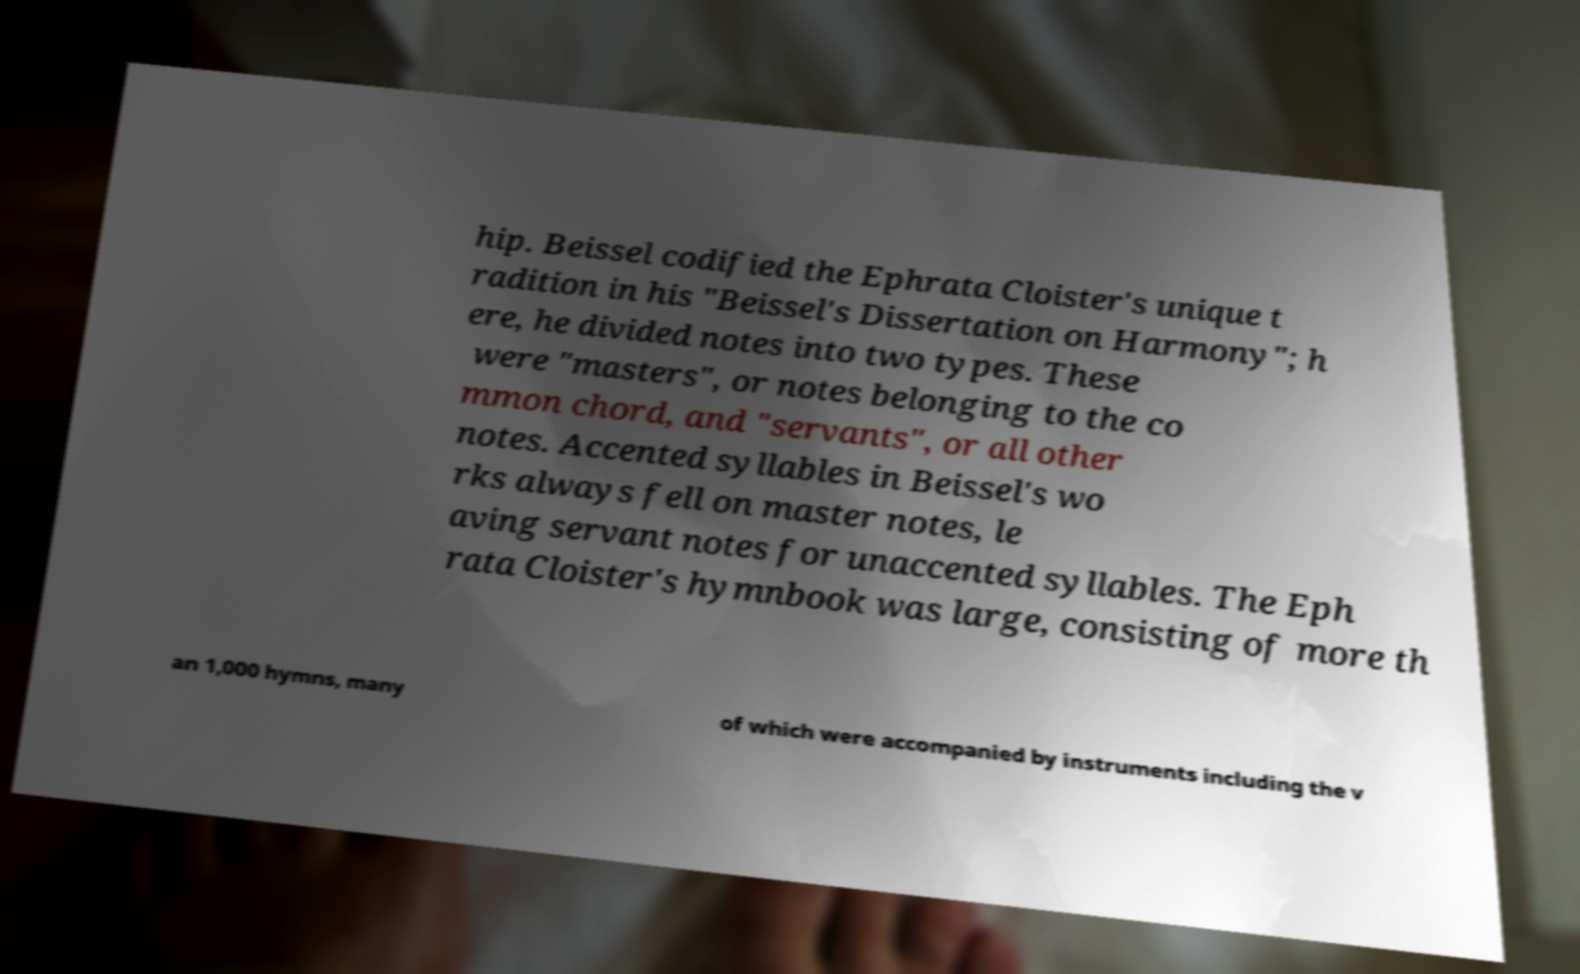Can you accurately transcribe the text from the provided image for me? hip. Beissel codified the Ephrata Cloister's unique t radition in his "Beissel's Dissertation on Harmony"; h ere, he divided notes into two types. These were "masters", or notes belonging to the co mmon chord, and "servants", or all other notes. Accented syllables in Beissel's wo rks always fell on master notes, le aving servant notes for unaccented syllables. The Eph rata Cloister's hymnbook was large, consisting of more th an 1,000 hymns, many of which were accompanied by instruments including the v 